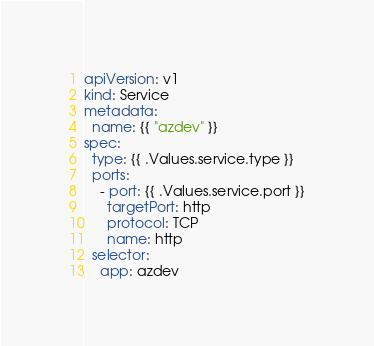<code> <loc_0><loc_0><loc_500><loc_500><_YAML_>apiVersion: v1
kind: Service
metadata:
  name: {{ "azdev" }}
spec:
  type: {{ .Values.service.type }}
  ports:
    - port: {{ .Values.service.port }}
      targetPort: http
      protocol: TCP
      name: http
  selector:
    app: azdev
</code> 